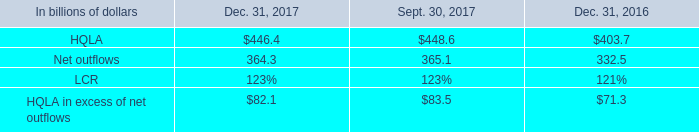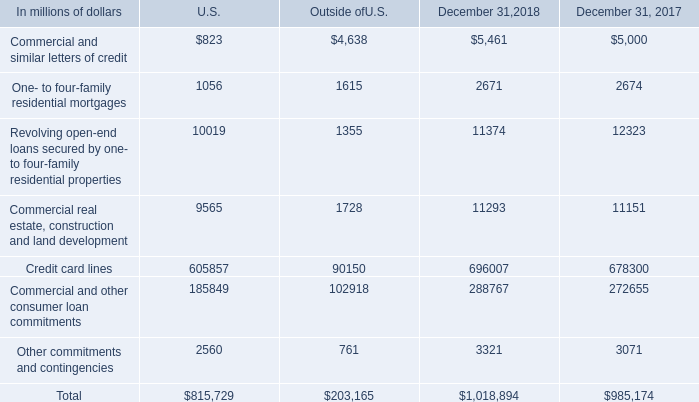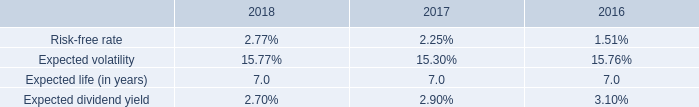what was the credit commitments and lines of credit total from 2017 to 2018 
Computations: ((1018894 - 985174) / 985174)
Answer: 0.03423. 